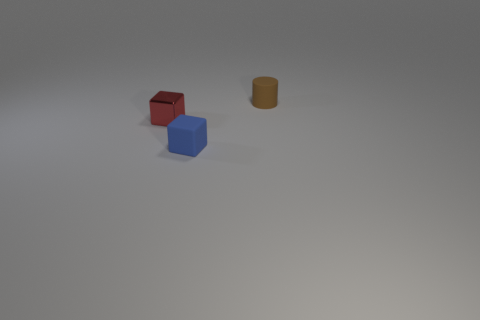Add 2 tiny red cubes. How many objects exist? 5 Subtract all blocks. How many objects are left? 1 Subtract all small blue cubes. Subtract all big purple matte spheres. How many objects are left? 2 Add 1 tiny brown matte things. How many tiny brown matte things are left? 2 Add 1 cylinders. How many cylinders exist? 2 Subtract 0 brown balls. How many objects are left? 3 